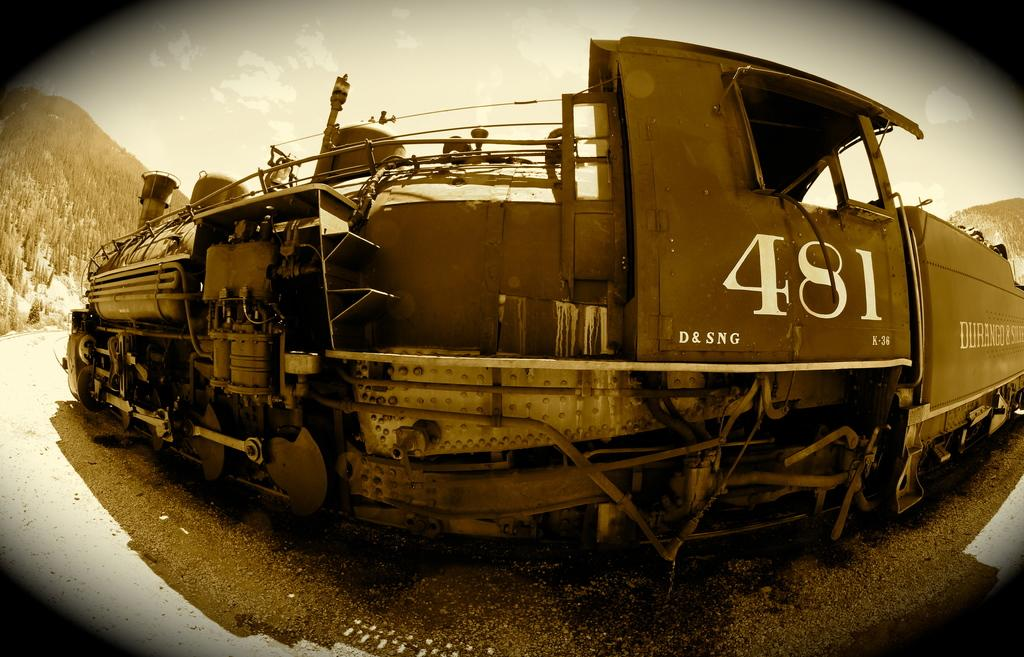<image>
Describe the image concisely. An old time steam locomotive with the number "481" printed on the side. 